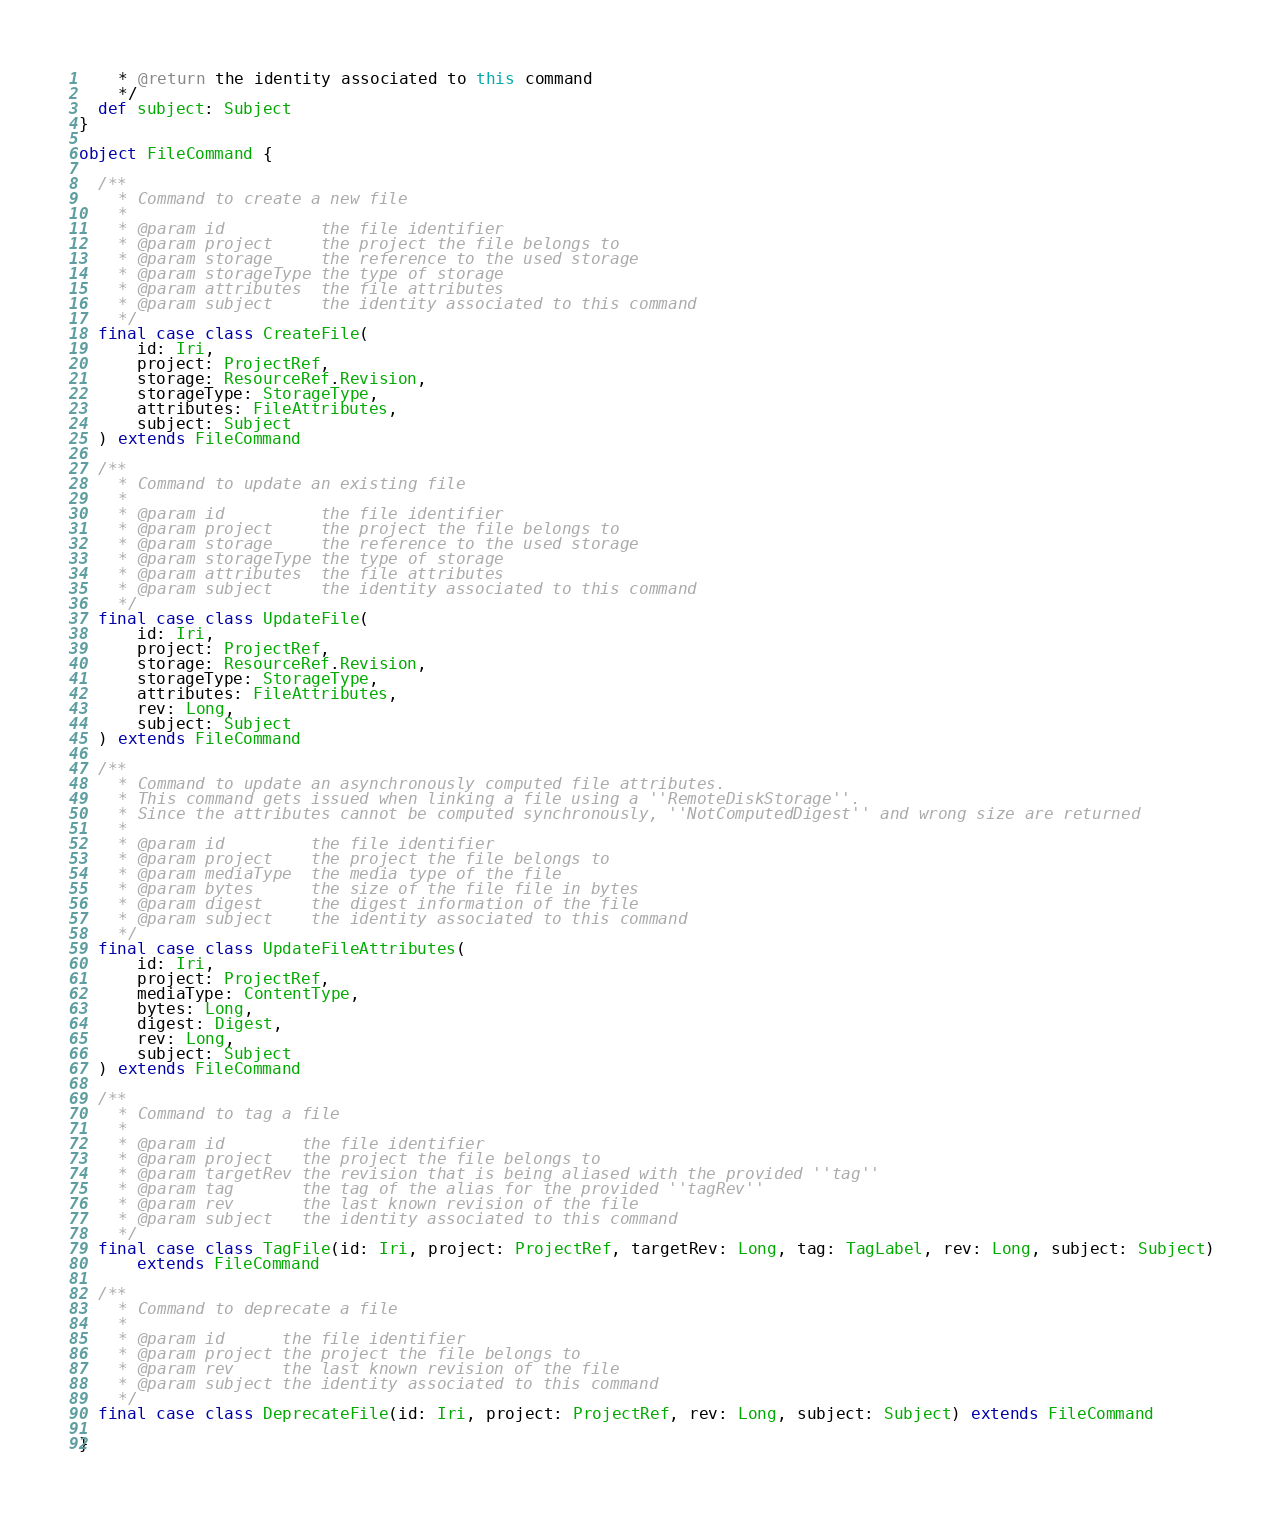<code> <loc_0><loc_0><loc_500><loc_500><_Scala_>    * @return the identity associated to this command
    */
  def subject: Subject
}

object FileCommand {

  /**
    * Command to create a new file
    *
    * @param id          the file identifier
    * @param project     the project the file belongs to
    * @param storage     the reference to the used storage
    * @param storageType the type of storage
    * @param attributes  the file attributes
    * @param subject     the identity associated to this command
    */
  final case class CreateFile(
      id: Iri,
      project: ProjectRef,
      storage: ResourceRef.Revision,
      storageType: StorageType,
      attributes: FileAttributes,
      subject: Subject
  ) extends FileCommand

  /**
    * Command to update an existing file
    *
    * @param id          the file identifier
    * @param project     the project the file belongs to
    * @param storage     the reference to the used storage
    * @param storageType the type of storage
    * @param attributes  the file attributes
    * @param subject     the identity associated to this command
    */
  final case class UpdateFile(
      id: Iri,
      project: ProjectRef,
      storage: ResourceRef.Revision,
      storageType: StorageType,
      attributes: FileAttributes,
      rev: Long,
      subject: Subject
  ) extends FileCommand

  /**
    * Command to update an asynchronously computed file attributes.
    * This command gets issued when linking a file using a ''RemoteDiskStorage''.
    * Since the attributes cannot be computed synchronously, ''NotComputedDigest'' and wrong size are returned
    *
    * @param id         the file identifier
    * @param project    the project the file belongs to
    * @param mediaType  the media type of the file
    * @param bytes      the size of the file file in bytes
    * @param digest     the digest information of the file
    * @param subject    the identity associated to this command
    */
  final case class UpdateFileAttributes(
      id: Iri,
      project: ProjectRef,
      mediaType: ContentType,
      bytes: Long,
      digest: Digest,
      rev: Long,
      subject: Subject
  ) extends FileCommand

  /**
    * Command to tag a file
    *
    * @param id        the file identifier
    * @param project   the project the file belongs to
    * @param targetRev the revision that is being aliased with the provided ''tag''
    * @param tag       the tag of the alias for the provided ''tagRev''
    * @param rev       the last known revision of the file
    * @param subject   the identity associated to this command
    */
  final case class TagFile(id: Iri, project: ProjectRef, targetRev: Long, tag: TagLabel, rev: Long, subject: Subject)
      extends FileCommand

  /**
    * Command to deprecate a file
    *
    * @param id      the file identifier
    * @param project the project the file belongs to
    * @param rev     the last known revision of the file
    * @param subject the identity associated to this command
    */
  final case class DeprecateFile(id: Iri, project: ProjectRef, rev: Long, subject: Subject) extends FileCommand

}
</code> 